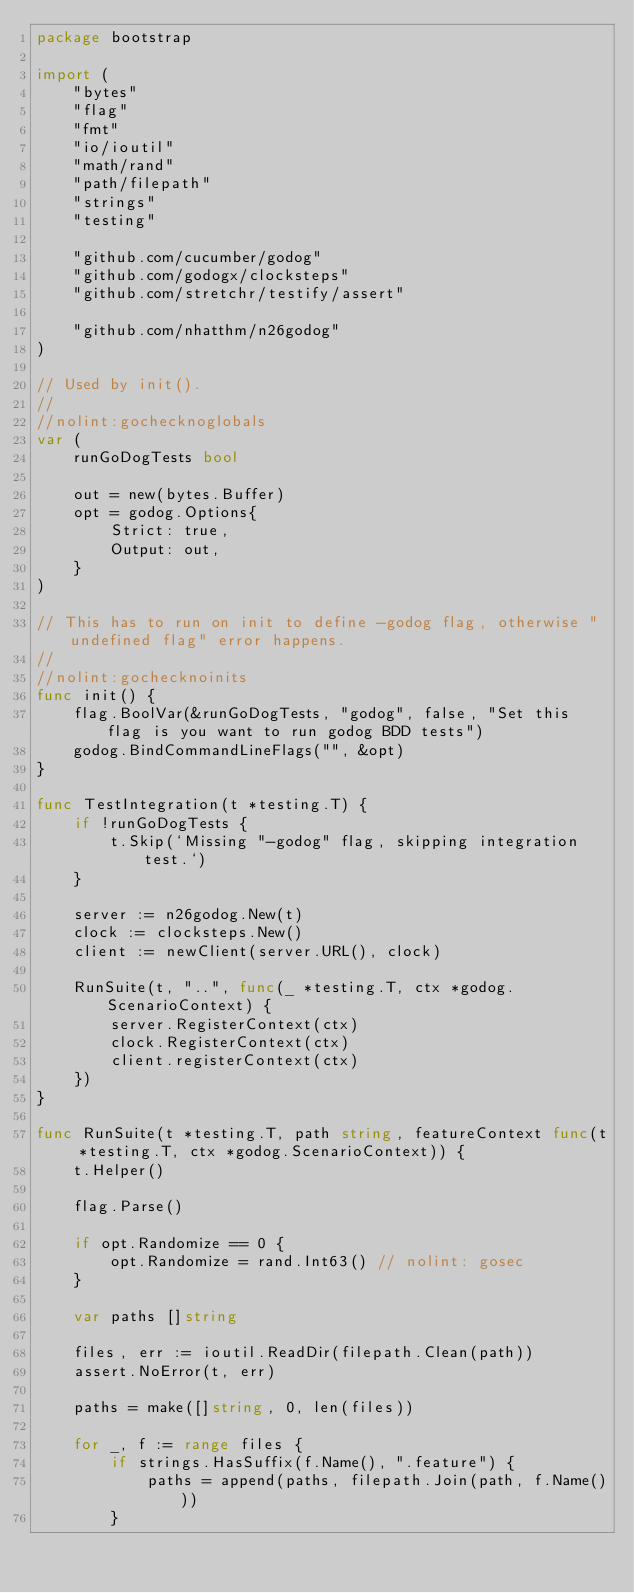<code> <loc_0><loc_0><loc_500><loc_500><_Go_>package bootstrap

import (
	"bytes"
	"flag"
	"fmt"
	"io/ioutil"
	"math/rand"
	"path/filepath"
	"strings"
	"testing"

	"github.com/cucumber/godog"
	"github.com/godogx/clocksteps"
	"github.com/stretchr/testify/assert"

	"github.com/nhatthm/n26godog"
)

// Used by init().
//
//nolint:gochecknoglobals
var (
	runGoDogTests bool

	out = new(bytes.Buffer)
	opt = godog.Options{
		Strict: true,
		Output: out,
	}
)

// This has to run on init to define -godog flag, otherwise "undefined flag" error happens.
//
//nolint:gochecknoinits
func init() {
	flag.BoolVar(&runGoDogTests, "godog", false, "Set this flag is you want to run godog BDD tests")
	godog.BindCommandLineFlags("", &opt)
}

func TestIntegration(t *testing.T) {
	if !runGoDogTests {
		t.Skip(`Missing "-godog" flag, skipping integration test.`)
	}

	server := n26godog.New(t)
	clock := clocksteps.New()
	client := newClient(server.URL(), clock)

	RunSuite(t, "..", func(_ *testing.T, ctx *godog.ScenarioContext) {
		server.RegisterContext(ctx)
		clock.RegisterContext(ctx)
		client.registerContext(ctx)
	})
}

func RunSuite(t *testing.T, path string, featureContext func(t *testing.T, ctx *godog.ScenarioContext)) {
	t.Helper()

	flag.Parse()

	if opt.Randomize == 0 {
		opt.Randomize = rand.Int63() // nolint: gosec
	}

	var paths []string

	files, err := ioutil.ReadDir(filepath.Clean(path))
	assert.NoError(t, err)

	paths = make([]string, 0, len(files))

	for _, f := range files {
		if strings.HasSuffix(f.Name(), ".feature") {
			paths = append(paths, filepath.Join(path, f.Name()))
		}</code> 